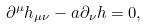<formula> <loc_0><loc_0><loc_500><loc_500>\partial ^ { \mu } h _ { \mu \nu } - a \partial _ { \nu } h = 0 ,</formula> 